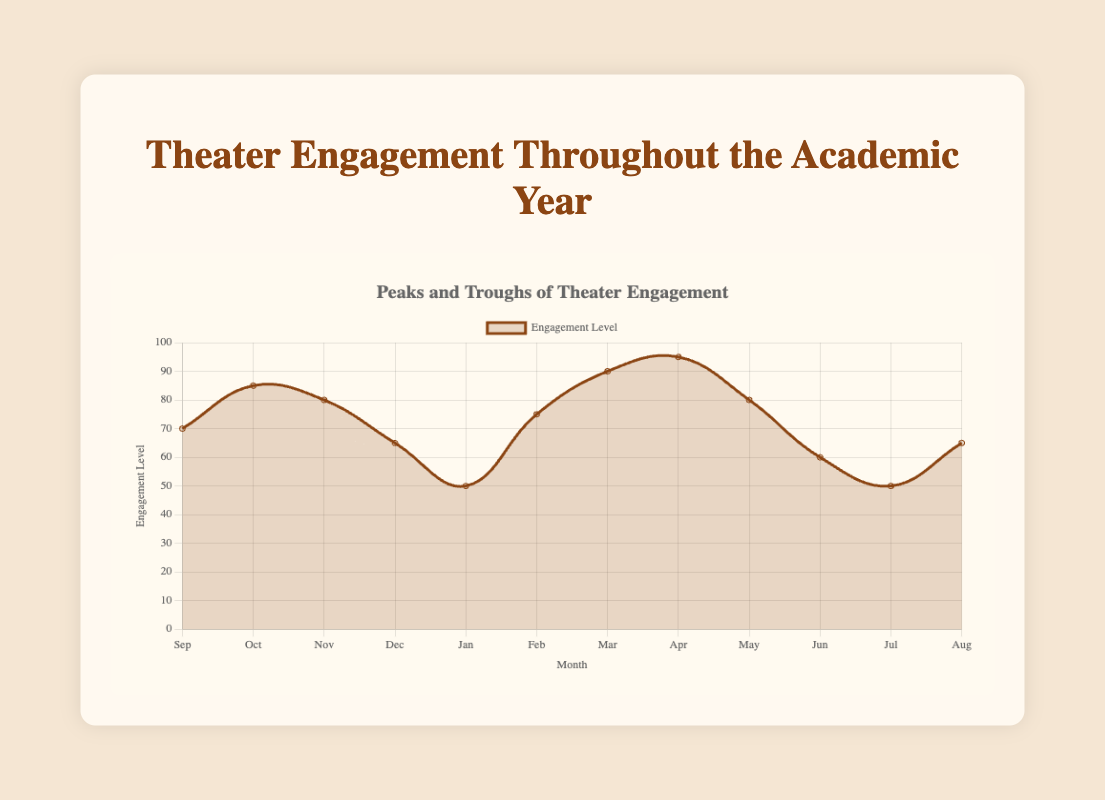What month has the highest engagement level? Look at the y-axis for engagement levels and identify the month with the highest point on the graph. The peak engagement level is at 95, seen in April.
Answer: April Which month shows the lowest engagement level, and what is it? Look for the lowest point on the graph and its corresponding month on the x-axis. The lowest engagement level is 50, occurring in January and July.
Answer: January and July How much does the engagement level change from December to January? Identify the engagement levels in December (65) and January (50), then calculate the difference: 65 - 50. The change is 15.
Answer: 15 During which months are there three performance projects underway? Examine the table for the months with three performance projects listed. These months are October, November, March, and May.
Answer: October, November, March, and May What is the average engagement level across the academic year? Add all the monthly engagement levels: 70 + 85 + 80 + 65 + 50 + 75 + 90 + 95 + 80 + 60 + 50 + 65 = 865. Divide by the number of months (12). The calculation is 865 / 12 ≈ 72.08.
Answer: 72.08 Which month has the greatest increase in engagement level compared to the previous month? Calculate the month-to-month differences: Oct-Sep (85-70=15), Nov-Oct (80-85=-5), Dec-Nov (65-80=-15), Jan-Dec (50-65=-15), Feb-Jan (75-50=25), Mar-Feb (90-75=15), Apr-Mar (95-90=5), May-Apr (80-95=-15), Jun-May (60-80=-20), Jul-Jun (50-60=-10), Aug-Jul (65-50=15). The greatest increase is from January to February, with a difference of 25.
Answer: February What is the difference in engagement levels between March and May? Find the engagement levels for March (90) and May (80) and calculate the difference: 90 - 80 = 10.
Answer: 10 Is there a month where the engagement level remains the same as the previous month? Compare each month's engagement level with the previous month. All months show a change, so there is no month with the same engagement level as the previous month.
Answer: No Describe the trend of engagement levels from March to April. Observe the graph lines from March (90) to April (95). The trend shows a steady increase in engagement level.
Answer: Steady increase 